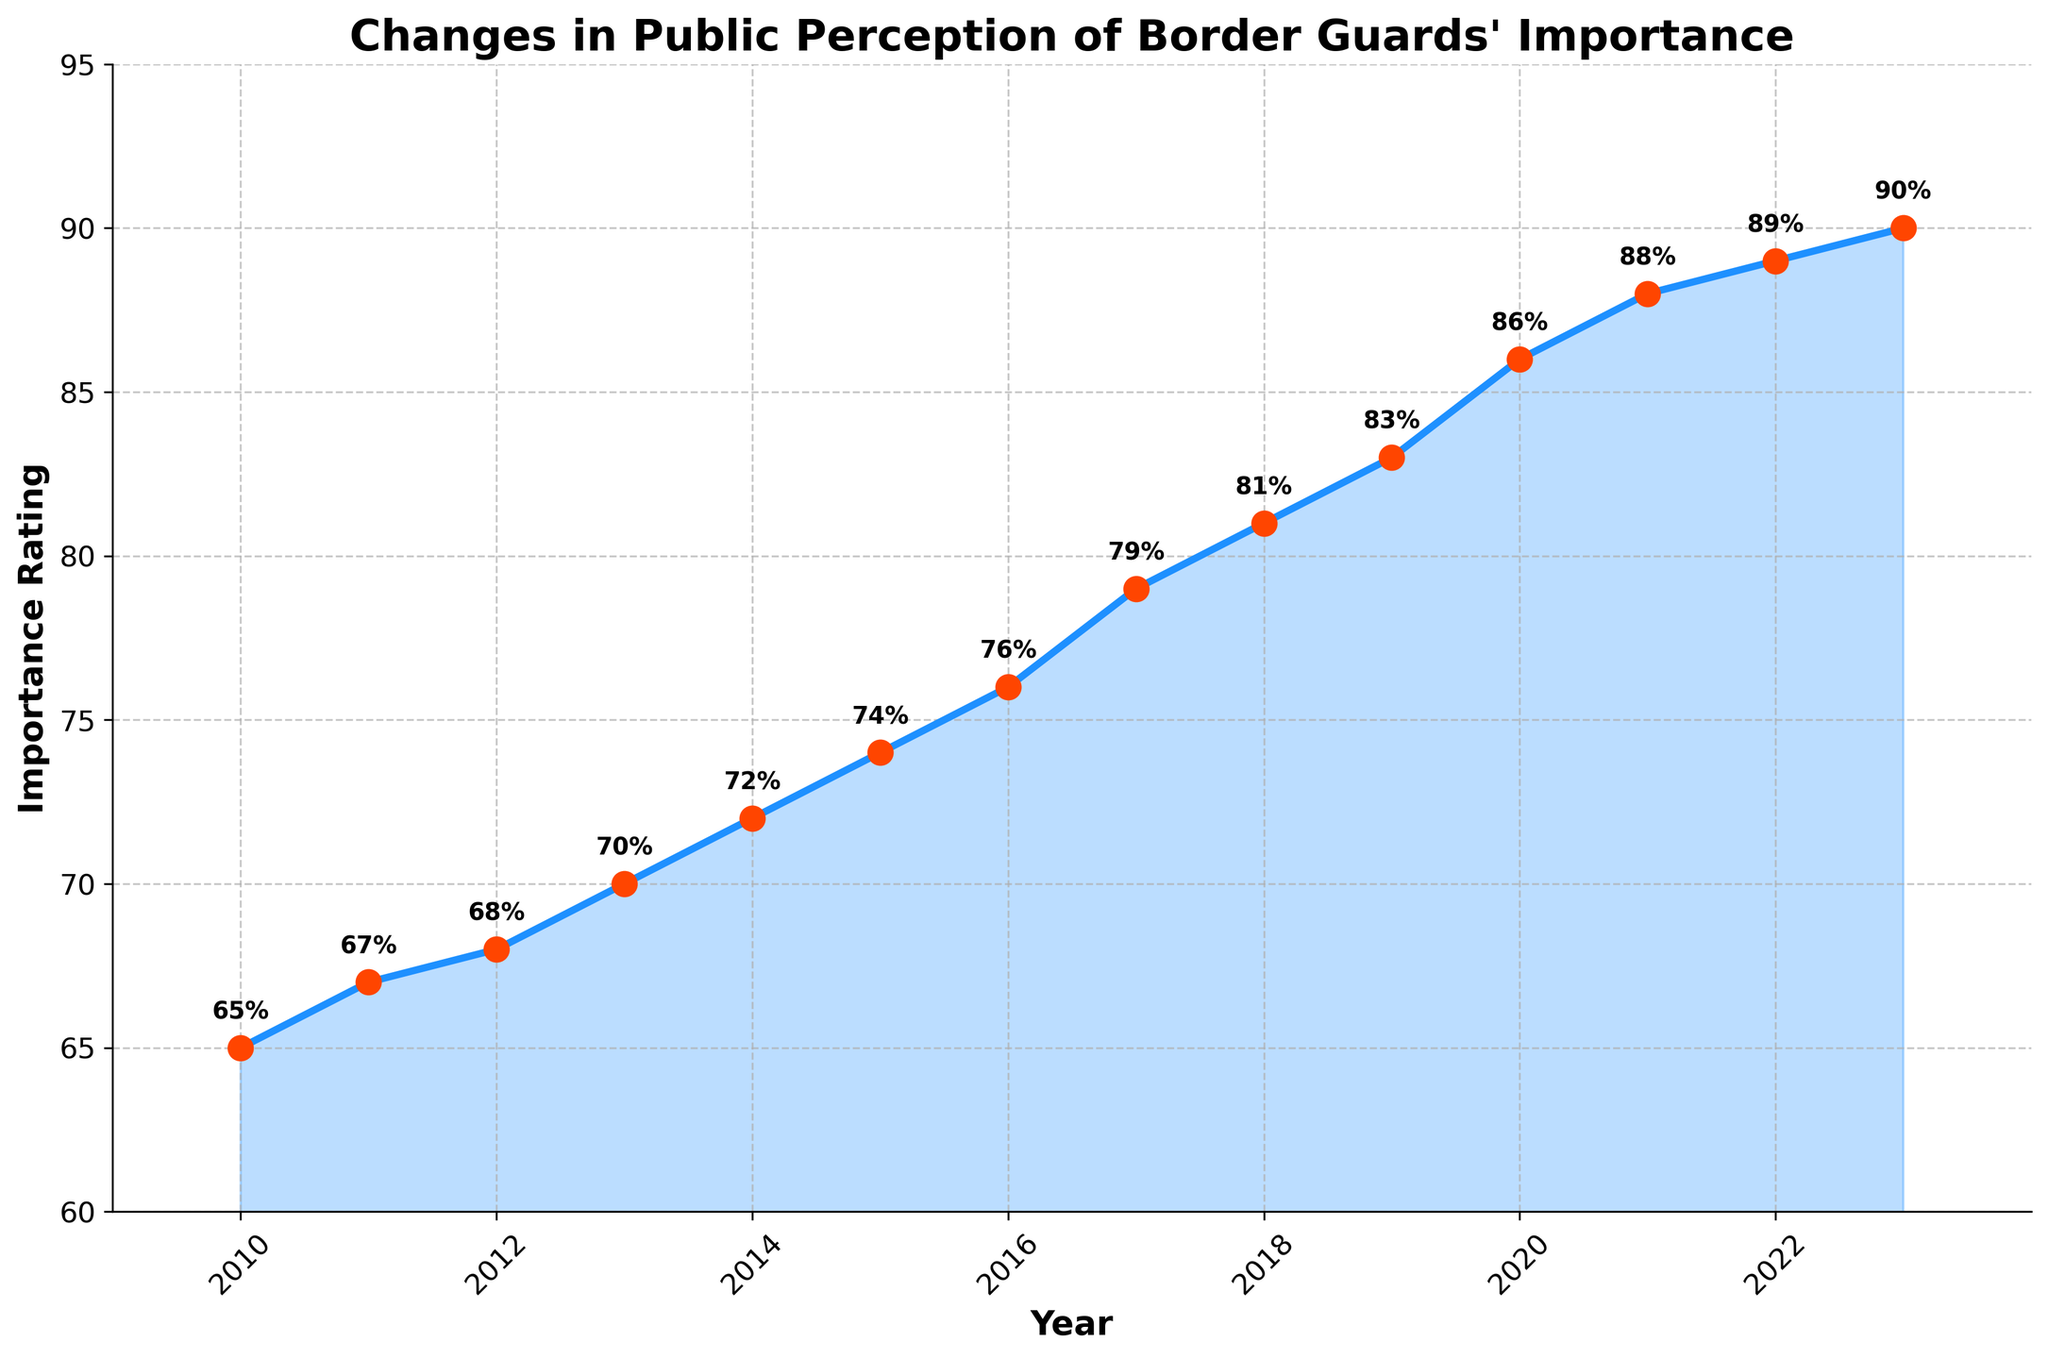What is the trend in the Importance Rating from 2010 to 2023? By examining the figure, you can see that the Importance Rating consistently increases each year from 2010 to 2023. This indicates a positive trend showing that public perception of border guards' importance is steadily improving.
Answer: Increasing What was the highest recorded Importance Rating between 2010 and 2023? The figure visually demonstrates the data points for each year, with the highest point being in 2023 where the Importance Rating reaches 90%.
Answer: 90% Which year shows the largest increase in Importance Rating compared to the previous year? By looking at the values in the chart, the biggest jump occurs between 2019 and 2020, where the Importance Rating increases from 83% to 86%, a difference of 3 percentage points.
Answer: 2020 What is the average Importance Rating over the period from 2010 to 2023? To find the average, sum all the Importance Ratings from 2010 to 2023 and divide by the number of years: (65 + 67 + 68 + 70 + 72 + 74 + 76 + 79 + 81 + 83 + 86 + 88 + 89 + 90) / 14 = 75.
Answer: 75 How much did the Importance Rating change from 2010 to 2023? To find the total change, subtract the Importance Rating in 2010 from that in 2023: 90% - 65% = 25%.
Answer: 25% In which year does the Importance Rating first reach or exceed 80%? According to the figure, the Importance Rating first reaches 81% in the year 2018.
Answer: 2018 Which two consecutive years had the smallest change in Importance Rating? By comparing the differences between each pair of consecutive years, the smallest change is between 2021 and 2022, where the rating increases from 88% to 89%, a change of 1 percentage point.
Answer: 2022 By how much did the Importance Rating increase from 2010 to 2020? Subtract the Importance Rating in 2010 from that in 2020: 86% - 65% = 21%.
Answer: 21% What is the color of the markers used to denote each year's Importance Rating? The markers are visually represented in red in the figure.
Answer: Red What is the median Importance Rating for the years 2010 to 2023? To find the median, list all Importance Ratings in order: 65, 67, 68, 70, 72, 74, 76, 79, 81, 83, 86, 88, 89, 90. The median is the average of the middle two values, 76 and 79: (76+79)/2 = 77.5.
Answer: 77.5 